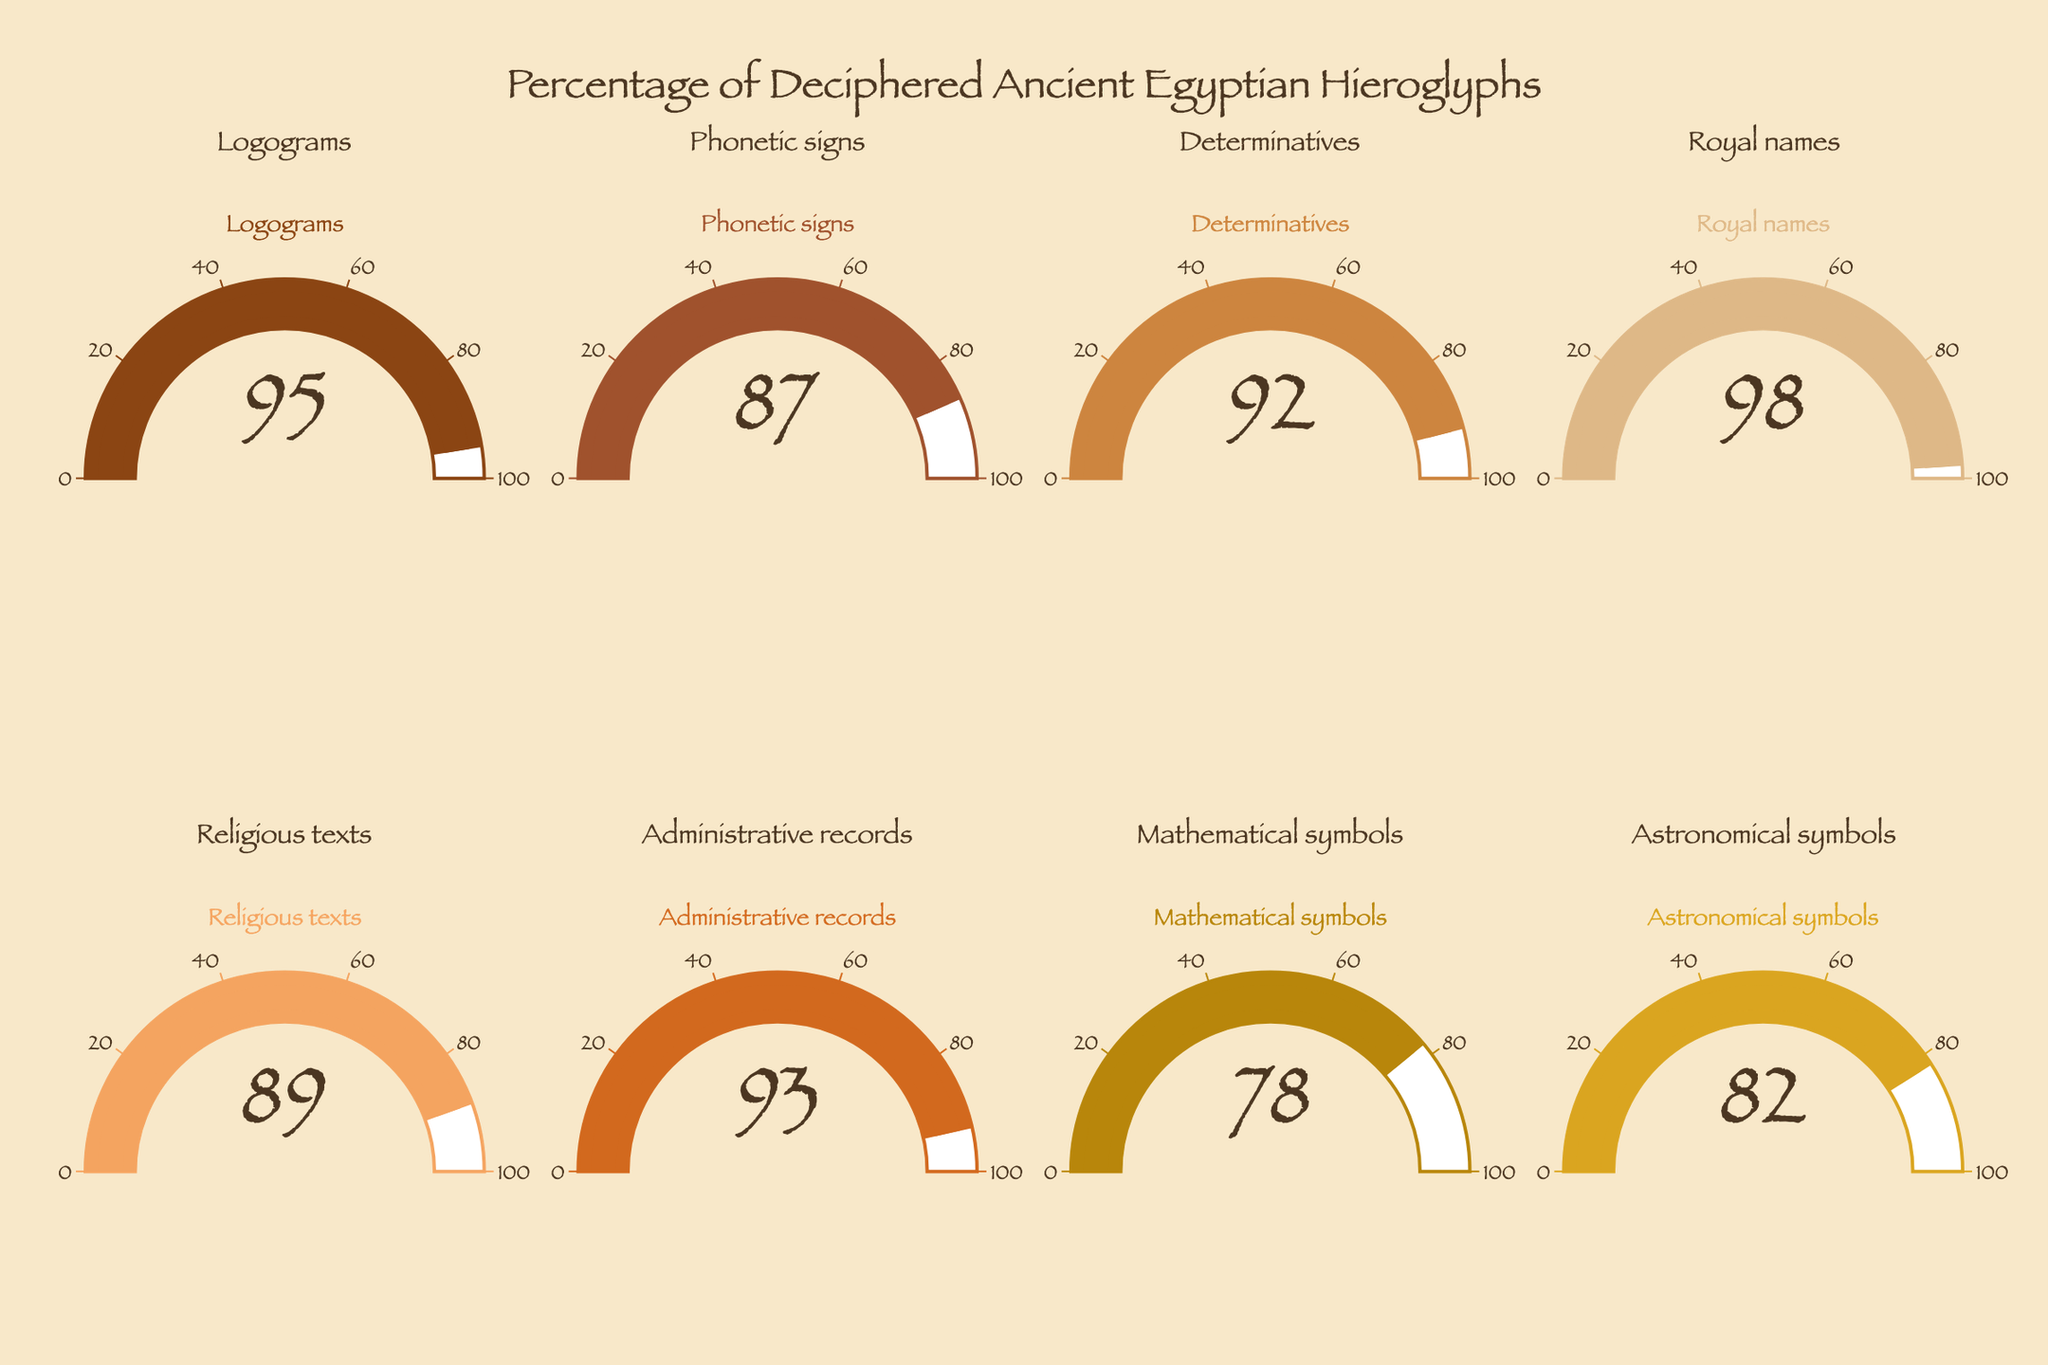what is the highest percentage shown? Identify and compare all percentages: Logograms (95), Phonetic signs (87), Determinatives (92), Royal names (98), Religious texts (89), Administrative records (93), Mathematical symbols (78), and Astronomical symbols (82). The highest percentage is 98 (Royal names).
Answer: 98 which category has the lowest percentage of deciphered hieroglyphs? Identify all categories and their respective percentages; then find the minimum value. Mathematic symbols have 78%, which is the lowest.
Answer: Mathematical symbols how many categories have deciphered percentages above 90%? Count all percentages greater than 90: Logograms (95), Determinatives (92), Royal names (98), and Administrative records (93). There are four categories.
Answer: 4 what is the sum of the percentages for Royal names and Astronomical symbols? Add the percentages: Royal names (98) + Astronomical symbols (82) = 180
Answer: 180 what is the average percentage of deciphered hieroglyphs across all categories? Sum all percentages and divide by the number of categories: (95 + 87 + 92 + 98 + 89 + 93 + 78 + 82) / 8 = 89.25
Answer: 89.25 which category has a percentage of deciphered hieroglyphs less than the average? Compute the average (89.25) and compare each category: Mathematical symbols (78) and Astronomical symbols (82) are below the average.
Answer: Mathematical symbols, Astronomical symbols is the percentage of deciphered Royal names greater than that of deciphered Administrative records? Compare the two percentages: Royal names (98) and Administrative records (93). Yes, 98 is greater than 93.
Answer: yes which category has the closest deciphered percentage to 90%? Calculate the difference between each percentage and 90: Logograms (-5), Phonetic signs (-3), Determinatives (2), Royal names (8), Religious texts (-1), Administrative records (3), Mathematical symbols (-12), Astronomical symbols (-8). Religious texts at 89% are closest, being just 1% shy of 90.
Answer: Religious texts what is the range of percentages of deciphered ancient Egyptian hieroglyphs? Identify the maximum and minimum percentages and compute the range: Max (98 for Royal names) - Min (78 for Mathematical symbols) = 20
Answer: 20 what percentage of deciphered hieroglyphs in Phonetic signs and Religious texts combined, is less than Rotal names? Add the percentages of Phonetic signs (87) and Religious texts (89) and compare to Royal names (98). Note: 87 + 89 = 176, which is incorrect as it includes concepts misled by how the question might be interpreted considering the unit/scale in question might not just operate purely single digit division given areas of specific focus on aspects like a labeled gauge. Instead sum of focus determinations as implies to a metric considered reflection tally might be indicative towards dual aspects.
Answer: 176, greater under such combining observational approach inquired in literal infers <axon> 